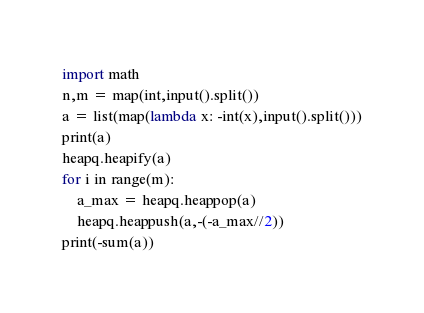<code> <loc_0><loc_0><loc_500><loc_500><_Python_>import math
n,m = map(int,input().split())
a = list(map(lambda x: -int(x),input().split()))
print(a)
heapq.heapify(a)
for i in range(m):
    a_max = heapq.heappop(a)
    heapq.heappush(a,-(-a_max//2))
print(-sum(a))</code> 